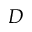Convert formula to latex. <formula><loc_0><loc_0><loc_500><loc_500>D</formula> 